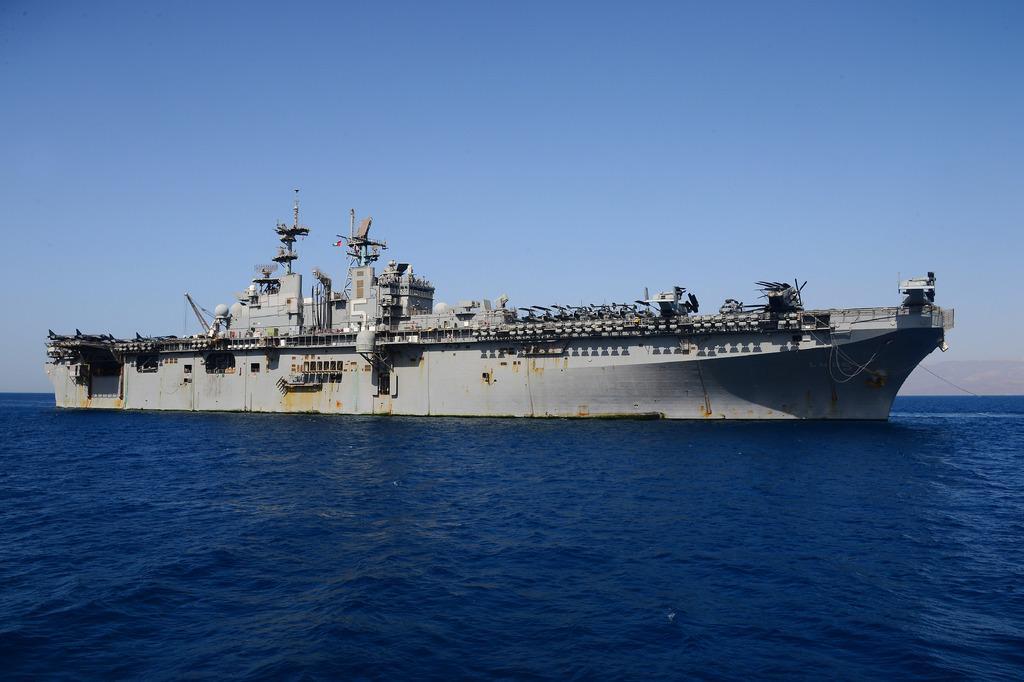Can you describe this image briefly? This image consists of a big ship in gray color. At the bottom, there is water. At the top, there is sky. 